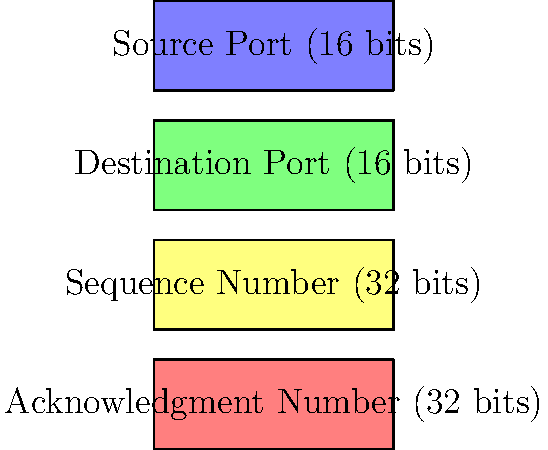Based on the packet header diagram shown above, which network protocol does this structure most likely represent? To identify the network protocol based on the given packet header diagram, let's analyze the fields:

1. The first field is "Source Port (16 bits)"
2. The second field is "Destination Port (16 bits)"
3. The third field is "Sequence Number (32 bits)"
4. The fourth field is "Acknowledgment Number (32 bits)"

These fields are characteristic of the Transmission Control Protocol (TCP) header. Let's break down why:

1. TCP uses source and destination ports to identify the sending and receiving application processes.
2. The sequence number is used to keep track of the order of data segments and ensure reliable delivery.
3. The acknowledgment number is used to inform the sender which bytes have been successfully received.

These features are specific to TCP and are not found in other common protocols like UDP (User Datagram Protocol) or ICMP (Internet Control Message Protocol).

UDP, for example, only has source and destination ports but lacks sequence and acknowledgment numbers, as it's a connectionless protocol.

ICMP doesn't use ports at all and has a different header structure.

Therefore, based on the presence of these specific fields, especially the sequence and acknowledgment numbers, we can conclude that this packet header represents the TCP protocol.
Answer: TCP (Transmission Control Protocol) 